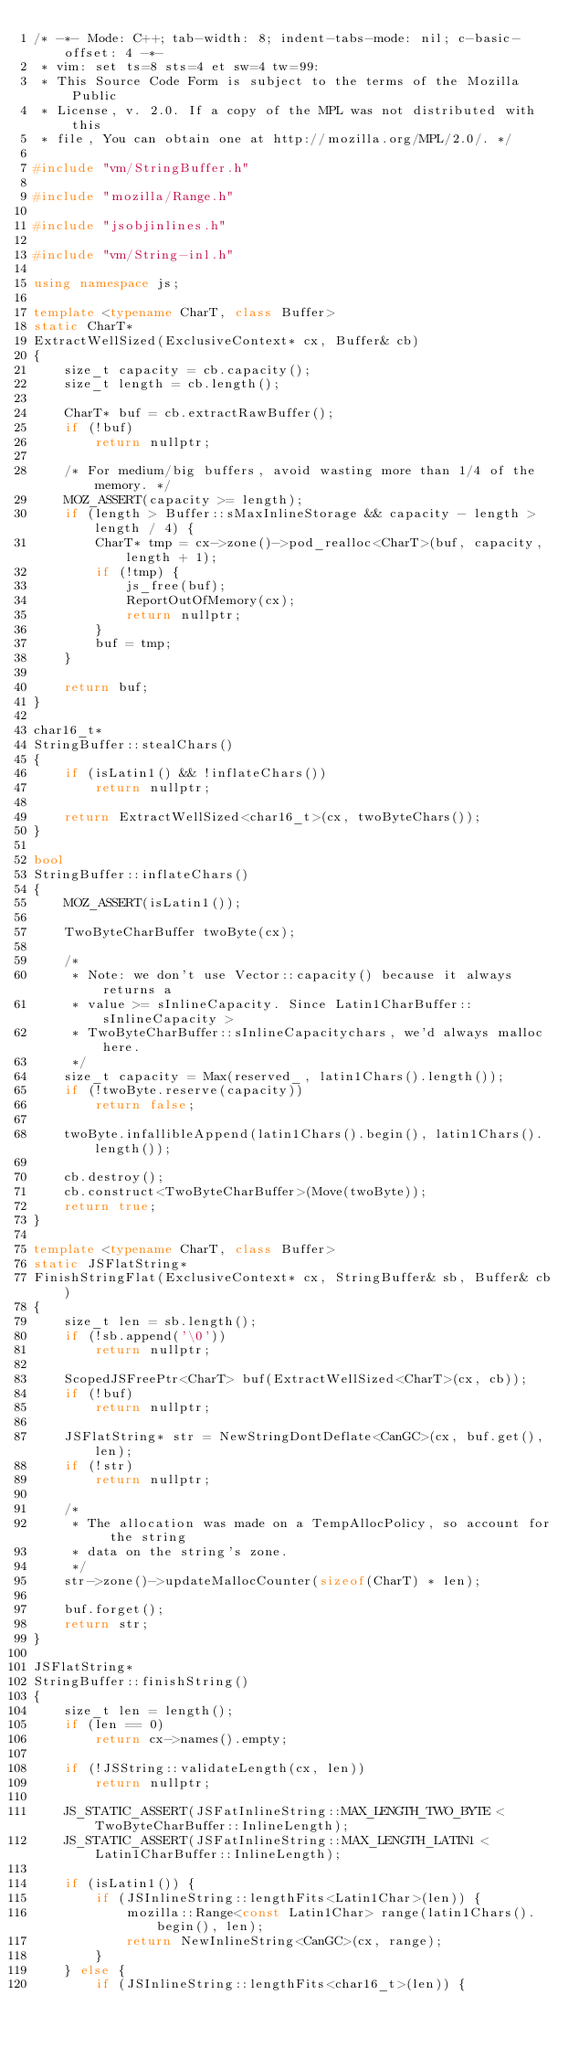<code> <loc_0><loc_0><loc_500><loc_500><_C++_>/* -*- Mode: C++; tab-width: 8; indent-tabs-mode: nil; c-basic-offset: 4 -*-
 * vim: set ts=8 sts=4 et sw=4 tw=99:
 * This Source Code Form is subject to the terms of the Mozilla Public
 * License, v. 2.0. If a copy of the MPL was not distributed with this
 * file, You can obtain one at http://mozilla.org/MPL/2.0/. */

#include "vm/StringBuffer.h"

#include "mozilla/Range.h"

#include "jsobjinlines.h"

#include "vm/String-inl.h"

using namespace js;

template <typename CharT, class Buffer>
static CharT*
ExtractWellSized(ExclusiveContext* cx, Buffer& cb)
{
    size_t capacity = cb.capacity();
    size_t length = cb.length();

    CharT* buf = cb.extractRawBuffer();
    if (!buf)
        return nullptr;

    /* For medium/big buffers, avoid wasting more than 1/4 of the memory. */
    MOZ_ASSERT(capacity >= length);
    if (length > Buffer::sMaxInlineStorage && capacity - length > length / 4) {
        CharT* tmp = cx->zone()->pod_realloc<CharT>(buf, capacity, length + 1);
        if (!tmp) {
            js_free(buf);
            ReportOutOfMemory(cx);
            return nullptr;
        }
        buf = tmp;
    }

    return buf;
}

char16_t*
StringBuffer::stealChars()
{
    if (isLatin1() && !inflateChars())
        return nullptr;

    return ExtractWellSized<char16_t>(cx, twoByteChars());
}

bool
StringBuffer::inflateChars()
{
    MOZ_ASSERT(isLatin1());

    TwoByteCharBuffer twoByte(cx);

    /*
     * Note: we don't use Vector::capacity() because it always returns a
     * value >= sInlineCapacity. Since Latin1CharBuffer::sInlineCapacity >
     * TwoByteCharBuffer::sInlineCapacitychars, we'd always malloc here.
     */
    size_t capacity = Max(reserved_, latin1Chars().length());
    if (!twoByte.reserve(capacity))
        return false;

    twoByte.infallibleAppend(latin1Chars().begin(), latin1Chars().length());

    cb.destroy();
    cb.construct<TwoByteCharBuffer>(Move(twoByte));
    return true;
}

template <typename CharT, class Buffer>
static JSFlatString*
FinishStringFlat(ExclusiveContext* cx, StringBuffer& sb, Buffer& cb)
{
    size_t len = sb.length();
    if (!sb.append('\0'))
        return nullptr;

    ScopedJSFreePtr<CharT> buf(ExtractWellSized<CharT>(cx, cb));
    if (!buf)
        return nullptr;

    JSFlatString* str = NewStringDontDeflate<CanGC>(cx, buf.get(), len);
    if (!str)
        return nullptr;

    /*
     * The allocation was made on a TempAllocPolicy, so account for the string
     * data on the string's zone.
     */
    str->zone()->updateMallocCounter(sizeof(CharT) * len);

    buf.forget();
    return str;
}

JSFlatString*
StringBuffer::finishString()
{
    size_t len = length();
    if (len == 0)
        return cx->names().empty;

    if (!JSString::validateLength(cx, len))
        return nullptr;

    JS_STATIC_ASSERT(JSFatInlineString::MAX_LENGTH_TWO_BYTE < TwoByteCharBuffer::InlineLength);
    JS_STATIC_ASSERT(JSFatInlineString::MAX_LENGTH_LATIN1 < Latin1CharBuffer::InlineLength);

    if (isLatin1()) {
        if (JSInlineString::lengthFits<Latin1Char>(len)) {
            mozilla::Range<const Latin1Char> range(latin1Chars().begin(), len);
            return NewInlineString<CanGC>(cx, range);
        }
    } else {
        if (JSInlineString::lengthFits<char16_t>(len)) {</code> 